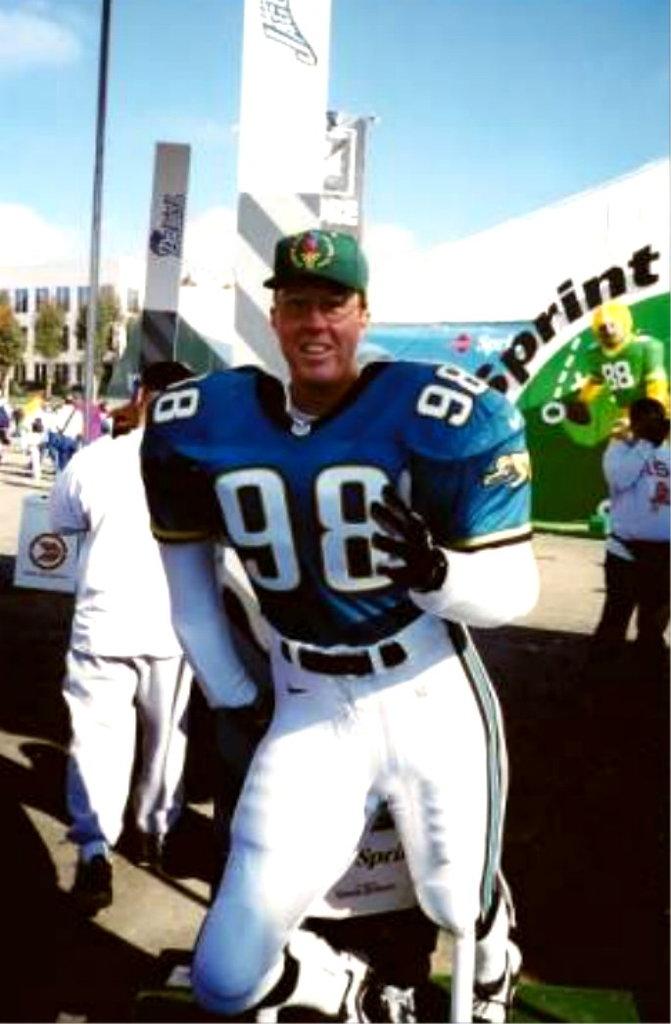What number jersey is the man wearing?
Provide a short and direct response. 98. What cell phone company is a sponsor?
Ensure brevity in your answer.  Sprint. 